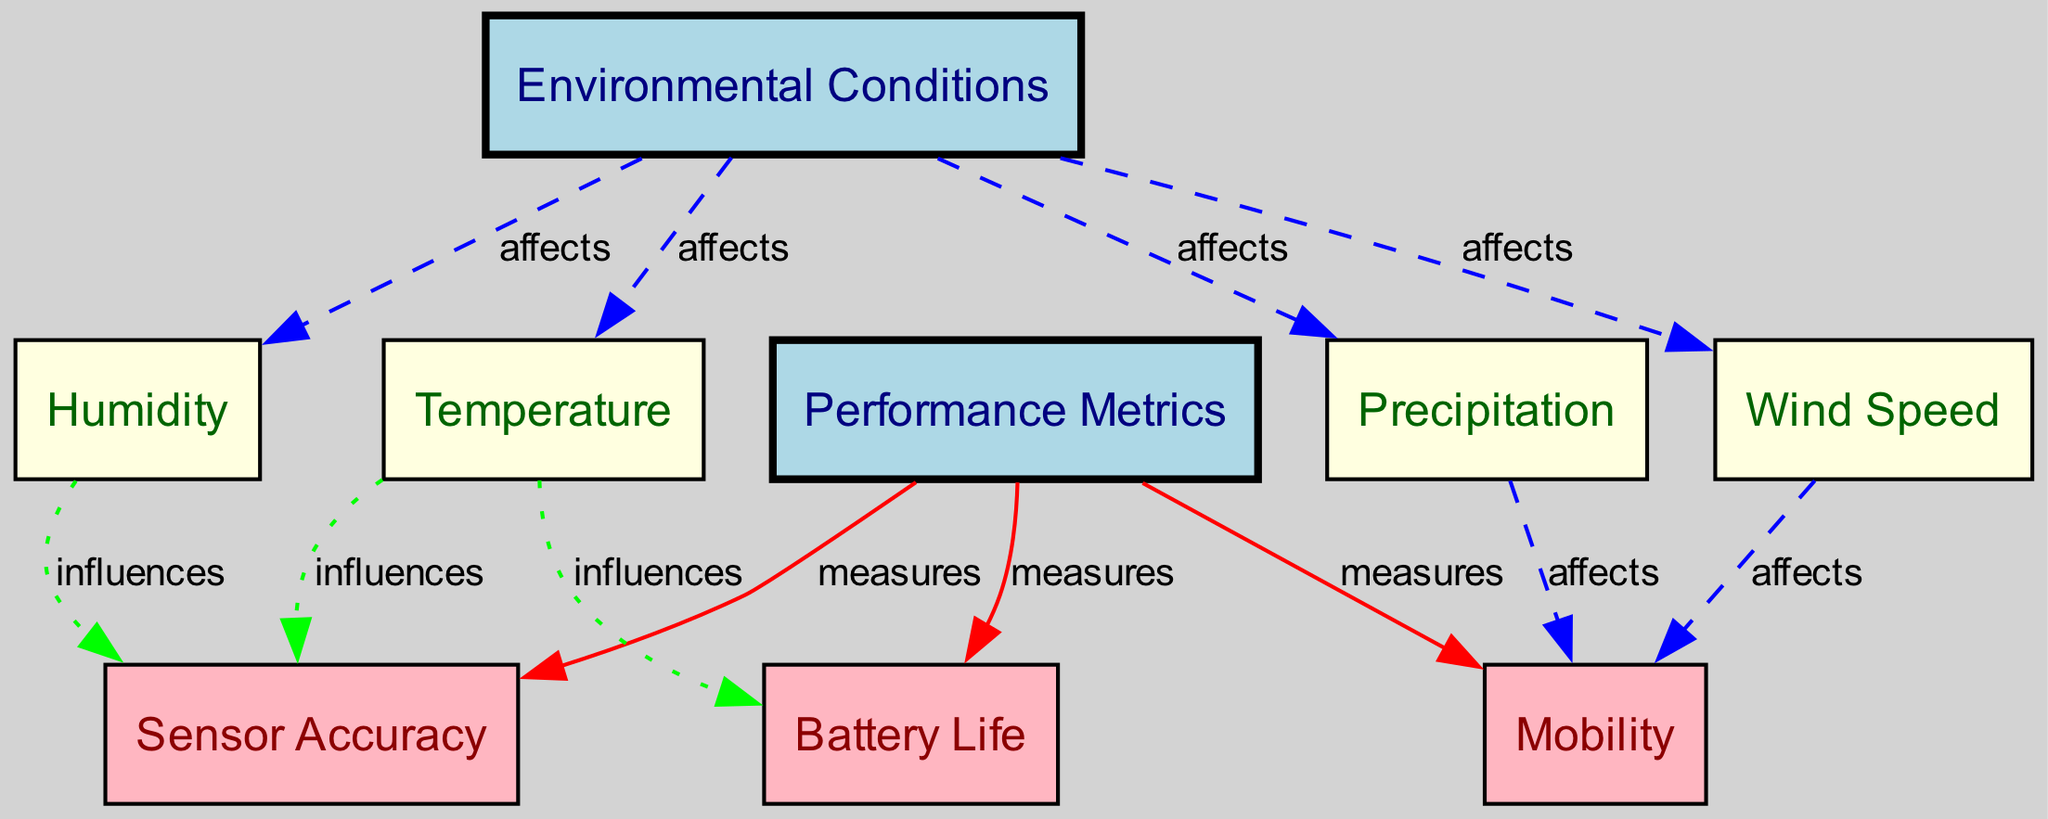What are the environmental conditions affecting the performance of outdoor robotics? The diagram indicates that the environmental conditions node affects four specific aspects: Temperature, Humidity, Precipitation, and Wind Speed. Each of these conditions is listed as a direct connection from the Environmental Conditions node.
Answer: Temperature, Humidity, Precipitation, Wind Speed How many performance metrics are represented in the diagram? There are three distinct performance metrics listed in the diagram: Battery Life, Sensor Accuracy, and Mobility. These metrics are connected to the Performance Metrics node.
Answer: Three Which environmental condition influences Battery Life? From the edges in the diagram, Temperature is the only environmental condition that influences Battery Life, indicated by a directed edge from Temperature to Battery Life.
Answer: Temperature How does Wind Speed affect performance? The diagram shows that Wind Speed influences Mobility. The relationship is depicted with a directed edge connecting Wind Speed to Mobility, suggesting that changes in Wind Speed can impact how well a robotic system can move.
Answer: Mobility What type of relationship exists between Humidity and Sensor Accuracy? The relationship between Humidity and Sensor Accuracy is an influence relationship, represented by a green dotted edge in the diagram that shows Humidity influences Sensor Accuracy.
Answer: Influences Which performance metric is directly affected by Precipitation? According to the diagram, Precipitation directly affects Mobility, as indicated by the dashed blue edge leading from Precipitation to Mobility.
Answer: Mobility What color represents edges that indicate influence in the diagram? The edges that indicate influence in the diagram are represented in green color, along with a dotted line style. This is consistent throughout the connections where influence is the described relationship.
Answer: Green How many edges originate from the Environmental Conditions node? The Environmental Conditions node has four originating edges pointing to Temperature, Humidity, Precipitation, and Wind Speed, indicating it affects all these environmental factors.
Answer: Four 